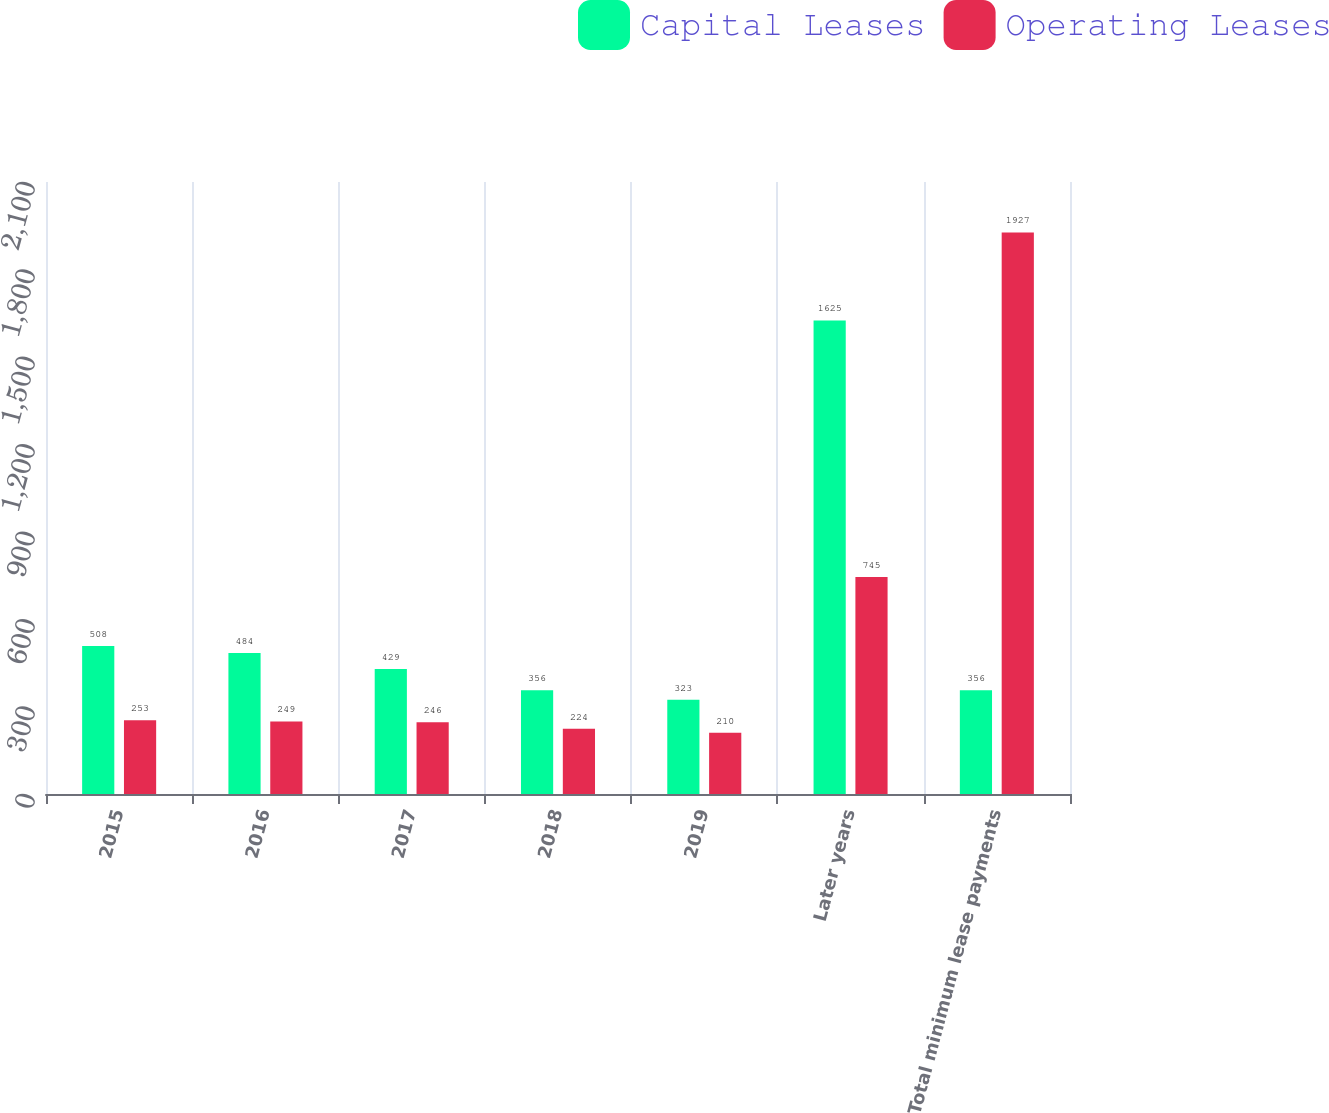Convert chart to OTSL. <chart><loc_0><loc_0><loc_500><loc_500><stacked_bar_chart><ecel><fcel>2015<fcel>2016<fcel>2017<fcel>2018<fcel>2019<fcel>Later years<fcel>Total minimum lease payments<nl><fcel>Capital Leases<fcel>508<fcel>484<fcel>429<fcel>356<fcel>323<fcel>1625<fcel>356<nl><fcel>Operating Leases<fcel>253<fcel>249<fcel>246<fcel>224<fcel>210<fcel>745<fcel>1927<nl></chart> 